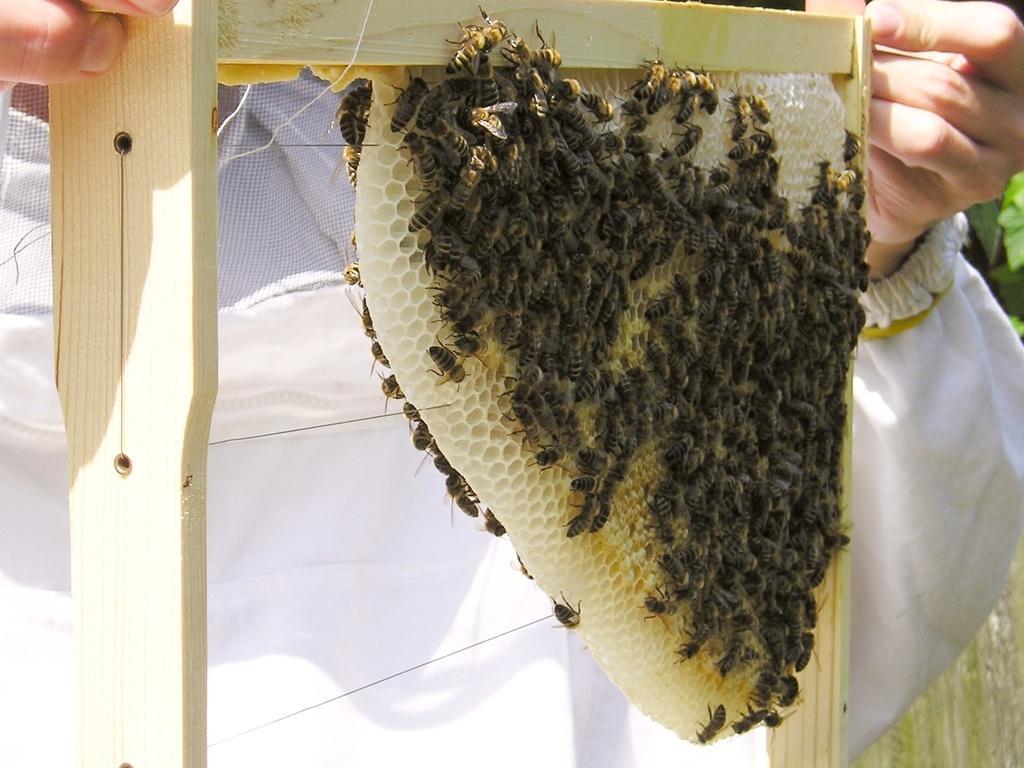Can you describe this image briefly? In this image we can see a person holding the honeycomb. We can also see the honey bees. On the right we can see the leaves. 